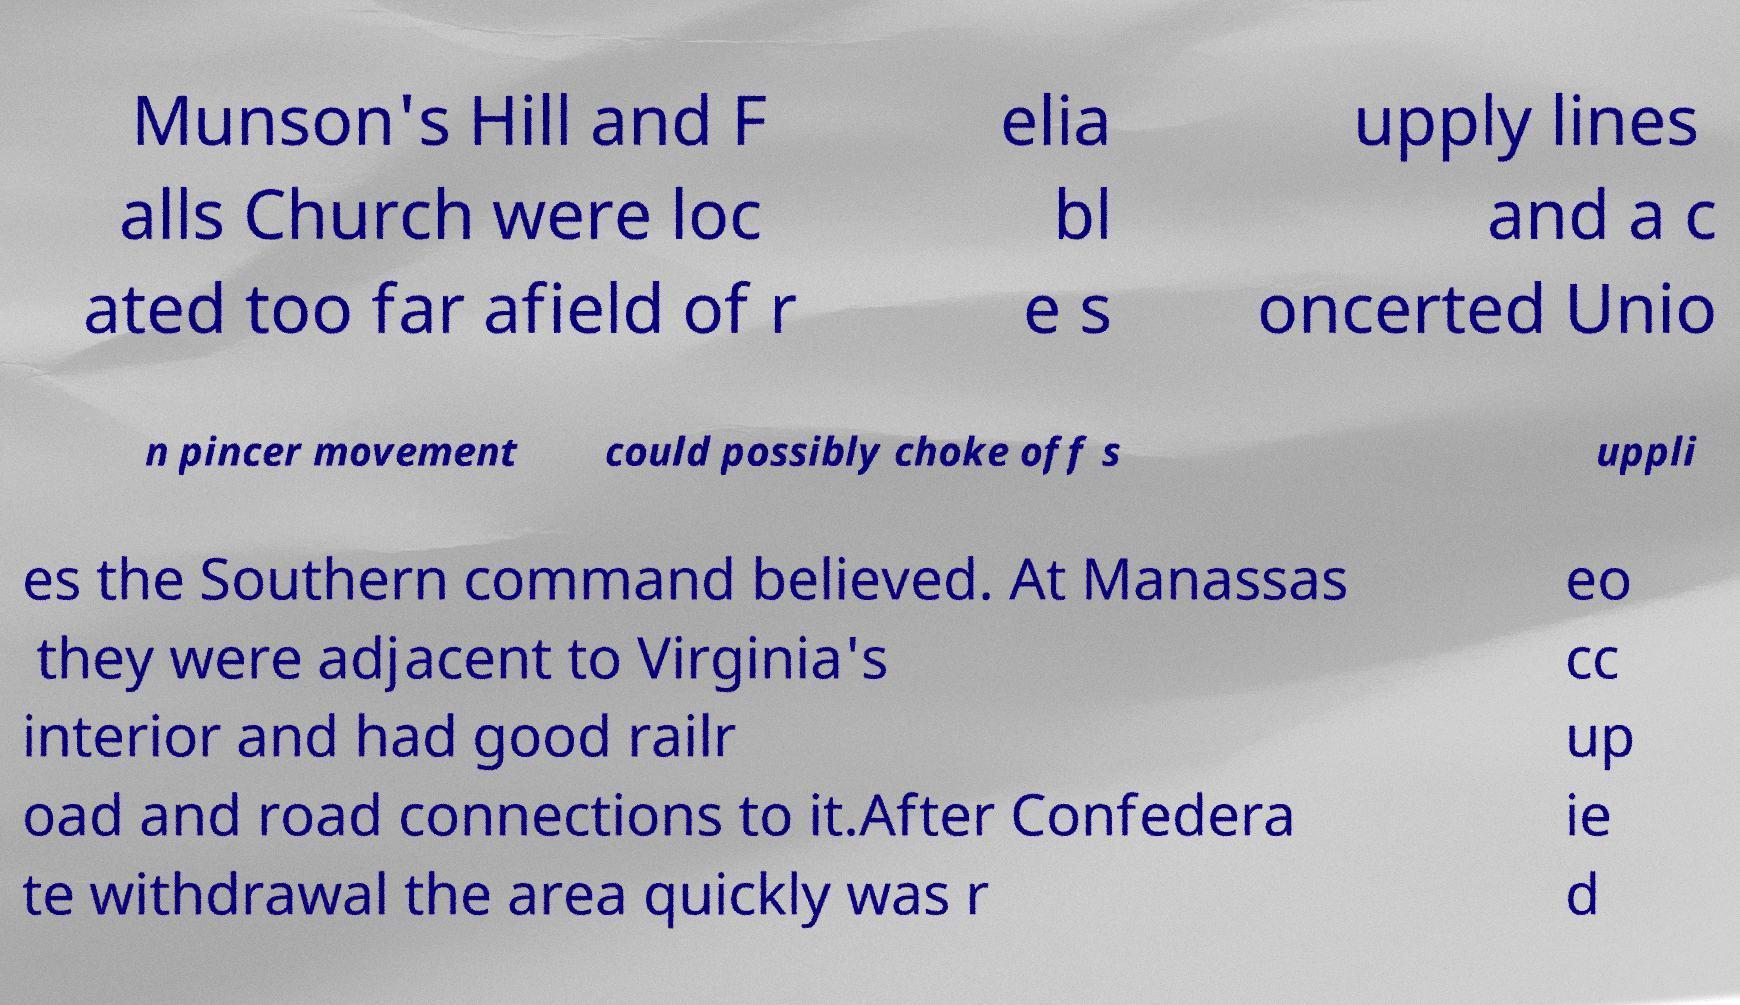I need the written content from this picture converted into text. Can you do that? Munson's Hill and F alls Church were loc ated too far afield of r elia bl e s upply lines and a c oncerted Unio n pincer movement could possibly choke off s uppli es the Southern command believed. At Manassas they were adjacent to Virginia's interior and had good railr oad and road connections to it.After Confedera te withdrawal the area quickly was r eo cc up ie d 